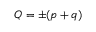<formula> <loc_0><loc_0><loc_500><loc_500>Q = \pm ( p + q )</formula> 